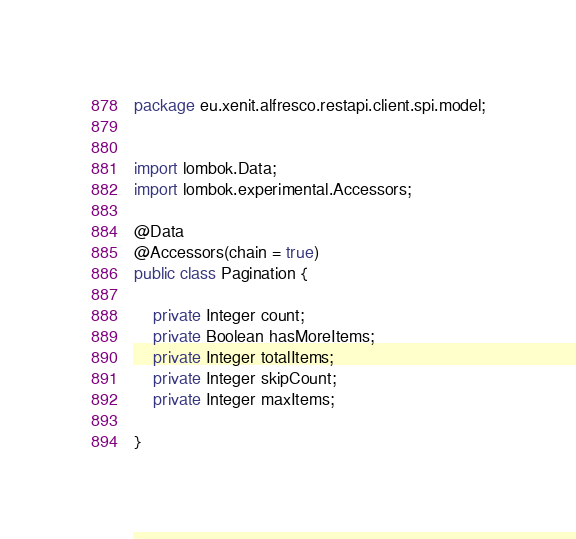<code> <loc_0><loc_0><loc_500><loc_500><_Java_>package eu.xenit.alfresco.restapi.client.spi.model;


import lombok.Data;
import lombok.experimental.Accessors;

@Data
@Accessors(chain = true)
public class Pagination {

    private Integer count;
    private Boolean hasMoreItems;
    private Integer totalItems;
    private Integer skipCount;
    private Integer maxItems;

}
</code> 